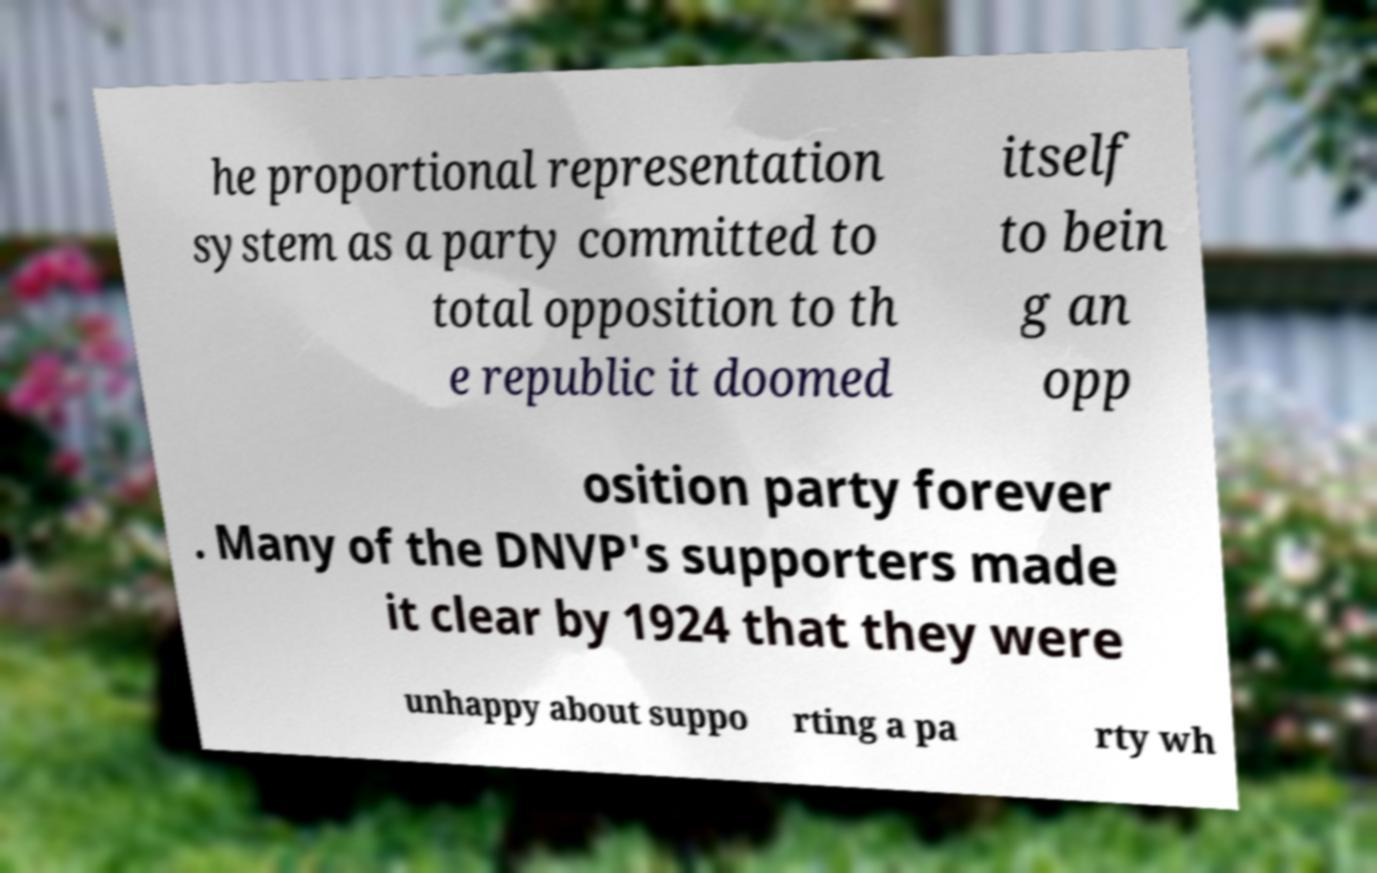There's text embedded in this image that I need extracted. Can you transcribe it verbatim? he proportional representation system as a party committed to total opposition to th e republic it doomed itself to bein g an opp osition party forever . Many of the DNVP's supporters made it clear by 1924 that they were unhappy about suppo rting a pa rty wh 